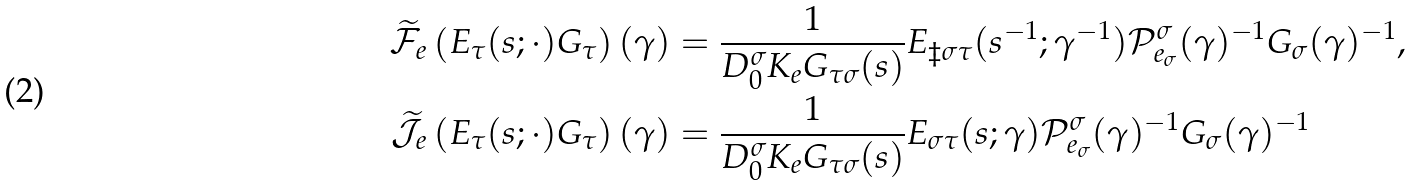Convert formula to latex. <formula><loc_0><loc_0><loc_500><loc_500>\widetilde { \mathcal { F } } _ { e } \left ( E _ { \tau } ( s ; \cdot ) G _ { \tau } \right ) ( \gamma ) & = \frac { 1 } { D _ { 0 } ^ { \sigma } K _ { e } G _ { \tau \sigma } ( s ) } E _ { \ddagger \sigma \tau } ( s ^ { - 1 } ; \gamma ^ { - 1 } ) \mathcal { P } _ { e _ { \sigma } } ^ { \sigma } ( \gamma ) ^ { - 1 } G _ { \sigma } ( \gamma ) ^ { - 1 } , \\ \widetilde { \mathcal { J } } _ { e } \left ( E _ { \tau } ( s ; \cdot ) G _ { \tau } \right ) ( \gamma ) & = \frac { 1 } { D _ { 0 } ^ { \sigma } K _ { e } G _ { \tau \sigma } ( s ) } E _ { \sigma \tau } ( s ; \gamma ) \mathcal { P } _ { e _ { \sigma } } ^ { \sigma } ( \gamma ) ^ { - 1 } G _ { \sigma } ( \gamma ) ^ { - 1 }</formula> 